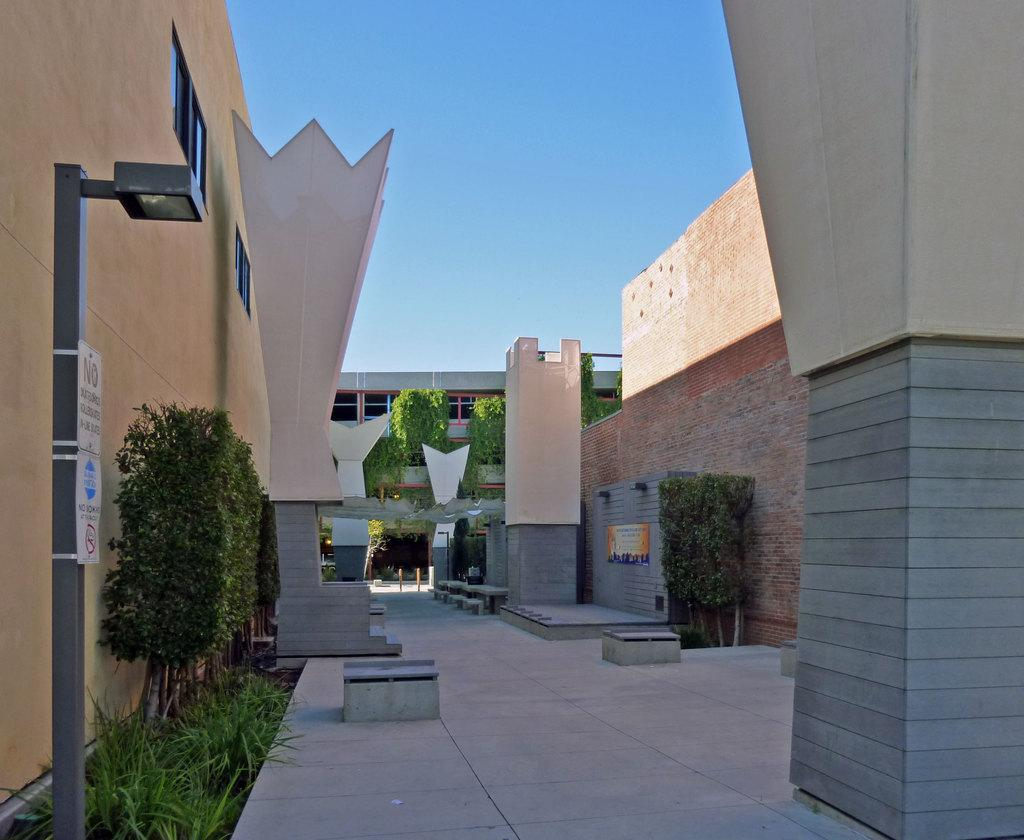Provide a one-sentence caption for the provided image. An empty path between 2 buildings with a no smoking sign on the left side. 